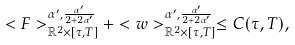Convert formula to latex. <formula><loc_0><loc_0><loc_500><loc_500>< F > ^ { { \alpha ^ { \prime } } , \frac { \alpha ^ { \prime } } { 2 + 2 { \alpha ^ { \prime } } } } _ { \mathbb { R } ^ { 2 } \times [ \tau , T ] } + < w > ^ { { \alpha ^ { \prime } } , \frac { \alpha ^ { \prime } } { 2 + 2 { \alpha ^ { \prime } } } } _ { \mathbb { R } ^ { 2 } \times [ \tau , T ] } \leq C ( \tau , T ) ,</formula> 